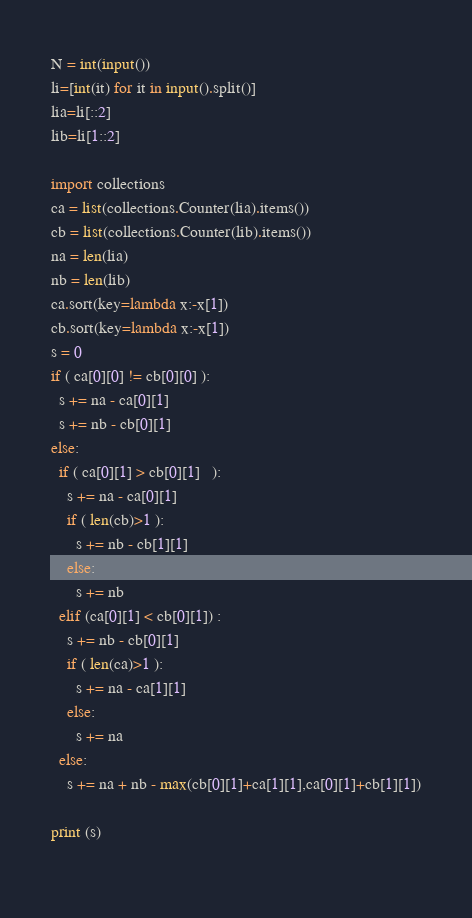<code> <loc_0><loc_0><loc_500><loc_500><_Python_>N = int(input())
li=[int(it) for it in input().split()]
lia=li[::2]
lib=li[1::2]

import collections
ca = list(collections.Counter(lia).items())
cb = list(collections.Counter(lib).items())
na = len(lia)
nb = len(lib)
ca.sort(key=lambda x:-x[1])
cb.sort(key=lambda x:-x[1])
s = 0
if ( ca[0][0] != cb[0][0] ):
  s += na - ca[0][1]
  s += nb - cb[0][1]
else:
  if ( ca[0][1] > cb[0][1]   ):
    s += na - ca[0][1]
    if ( len(cb)>1 ):
      s += nb - cb[1][1]
    else:
      s += nb
  elif (ca[0][1] < cb[0][1]) :
    s += nb - cb[0][1]
    if ( len(ca)>1 ):
      s += na - ca[1][1]
    else:
      s += na
  else:
    s += na + nb - max(cb[0][1]+ca[1][1],ca[0][1]+cb[1][1])
    
print (s)
  
</code> 